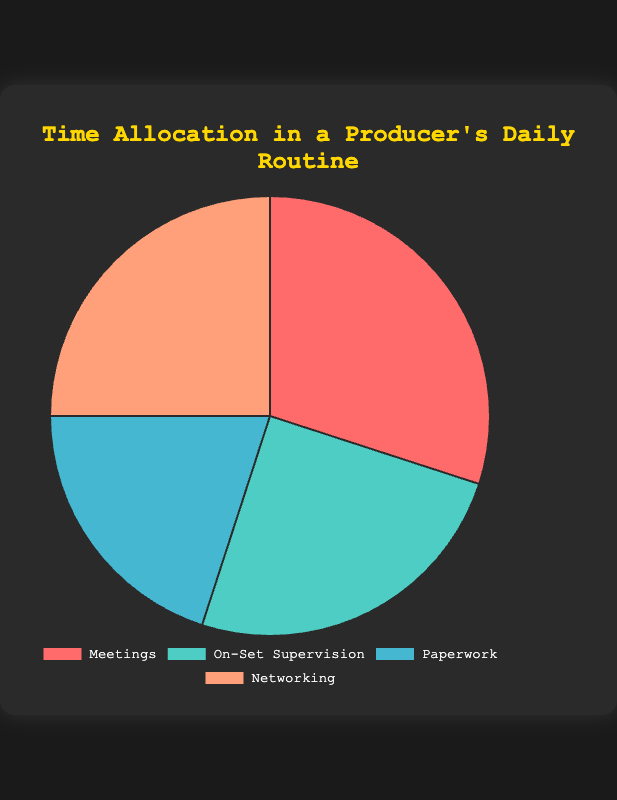What category takes up the most time in a producer's daily routine? By looking at the pie chart, we can see the percentage values for each category. The category with the highest percentage indicates the most time-consuming activity.
Answer: Meetings Which two categories have the same time allocation? Check the percentage values for each category and identify the ones that are equal. Both Networking and On-Set Supervision have the same values.
Answer: Networking and On-Set Supervision How much more time is spent on Meetings compared to Paperwork? Subtract the percentage of time spent on Paperwork from the percentage of time spent on Meetings: 30% - 20% = 10%.
Answer: 10% What are the combined percentages of time spent on Networking and On-Set Supervision? Add the percentages of time for Networking and On-Set Supervision: 25% + 25% = 50%.
Answer: 50% Which category has the smallest time allocation? Check the pie chart for the category with the lowest percentage value.
Answer: Paperwork How do Meetings compare with On-Set Supervision in terms of percentage? Compare the percentage values listed. Meetings have 30%, and On-Set Supervision has 25%, so Meetings take up 5% more time.
Answer: Meetings have 5% more How does the time spent on Paperwork relate to the time spent on Networking? Check the percentage values for Paperwork (20%) and Networking (25%). Paperwork takes 5% less time than Networking.
Answer: Paperwork takes 5% less Which activity category is visually represented by the bright red color? Identify the bright red color segment in the pie chart (as described in the code, the first color is #FF6B6B, which corresponds to Meetings).
Answer: Meetings If the producer decides to cut their Networking time in half and add it to On-Set Supervision, what would the new time percentages be for these two categories? Initial Networking time is 25%, cutting it in half gives 12.5%. On-Set Supervision, initially at 25%, would increase by 12.5%, making it 37.5%. New percentages: Networking 12.5%, On-Set Supervision 37.5%.
Answer: Networking: 12.5%, On-Set Supervision: 37.5% If Meetings and On-Set Supervision are combined into one category, what percentage of the producer's day would this new category represent? Add the percentages of Meetings and On-Set Supervision: 30% + 25% = 55%.
Answer: 55% 